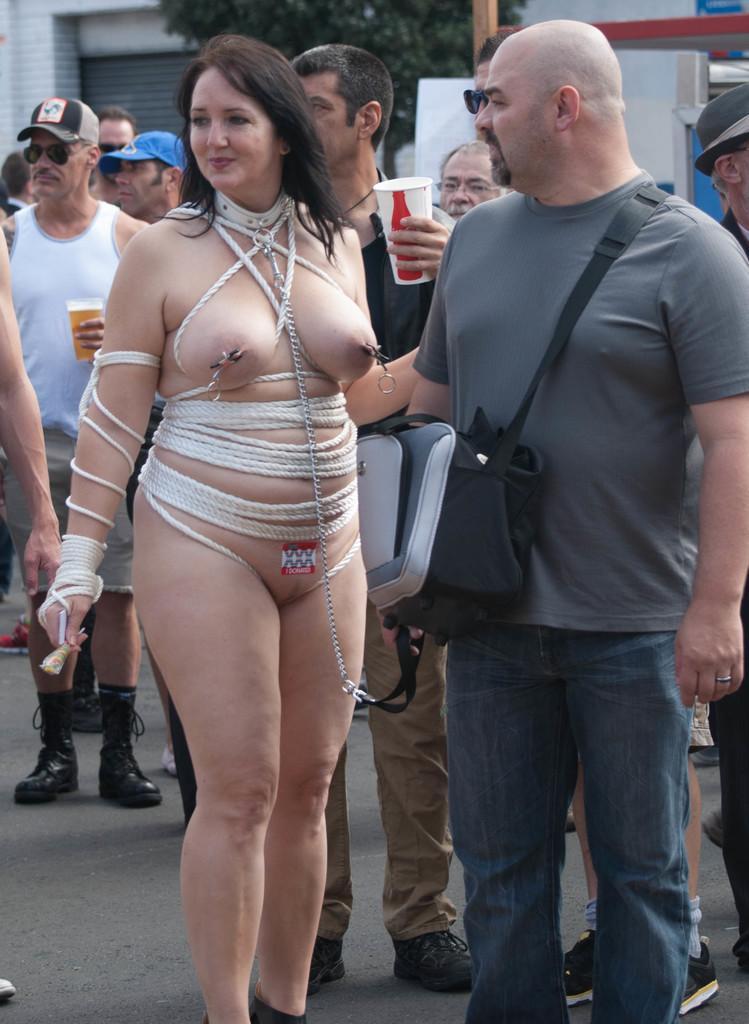How would you summarize this image in a sentence or two? In this picture we can see a group of people and in the background we can see a wall,trees. 